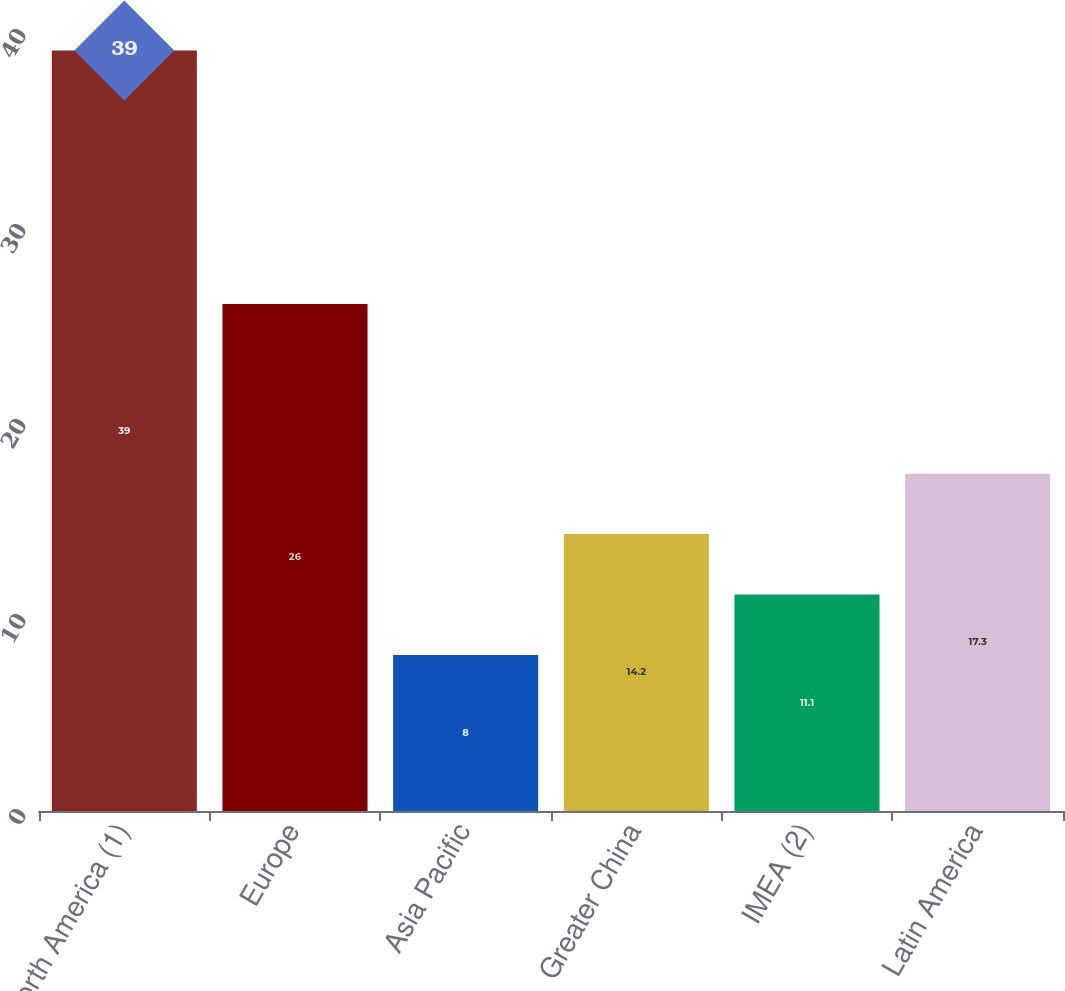<chart> <loc_0><loc_0><loc_500><loc_500><bar_chart><fcel>North America (1)<fcel>Europe<fcel>Asia Pacific<fcel>Greater China<fcel>IMEA (2)<fcel>Latin America<nl><fcel>39<fcel>26<fcel>8<fcel>14.2<fcel>11.1<fcel>17.3<nl></chart> 